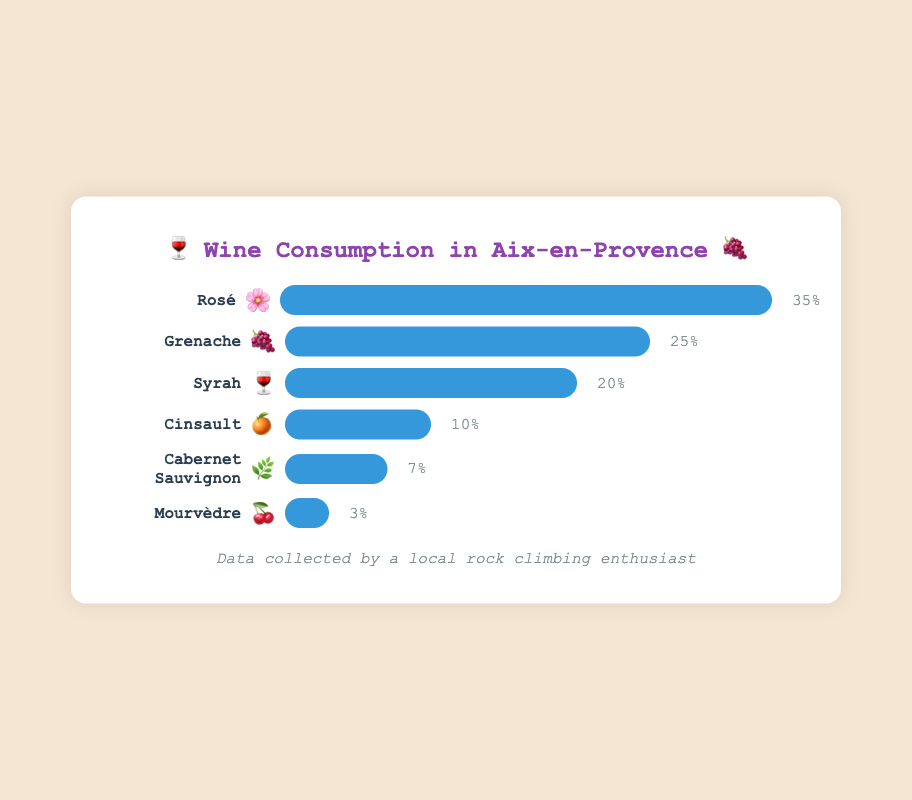What is the most consumed wine variety in Aix-en-Provence? By observing the figure, Rosé has the highest bar which represents 35% consumption.
Answer: Rosé Which wine variety has the lowest consumption? By checking the bars, Mourvèdre has the lowest consumption at 3%.
Answer: Mourvèdre How much more consumption does Rosé have compared to Cinsault? Rosé has a consumption of 35%, and Cinsault has 10%. The difference is 35% - 10% = 25%.
Answer: 25% What are the total consumption percentages of Grenache and Syrah combined? Grenache has 25% and Syrah has 20%. Their total is 25% + 20% = 45%.
Answer: 45% How much less consumption does Cabernet Sauvignon have compared to Syrah? Cabernet Sauvignon has 7% and Syrah has 20%. The difference is 20% - 7% = 13%.
Answer: 13% What's the combined consumption percentage of all varieties excluding Rosé? Excluding Rosé (35%), sum the rest: 25% + 20% + 10% + 7% + 3% = 65%.
Answer: 65% Which varieties have a consumption percentage greater than 10%? By looking at the bar lengths, Rosé, Grenache, and Syrah have more than 10% consumption.
Answer: Rosé, Grenache, Syrah How many wine varieties are depicted in the chart? The chart displays bars for each wine variety. Counting them gives a total of 6.
Answer: 6 Which wine variety has an emoji of 🍇? Observing the labels and emojis, Grenache is accompanied by the 🍇 emoji.
Answer: Grenache 